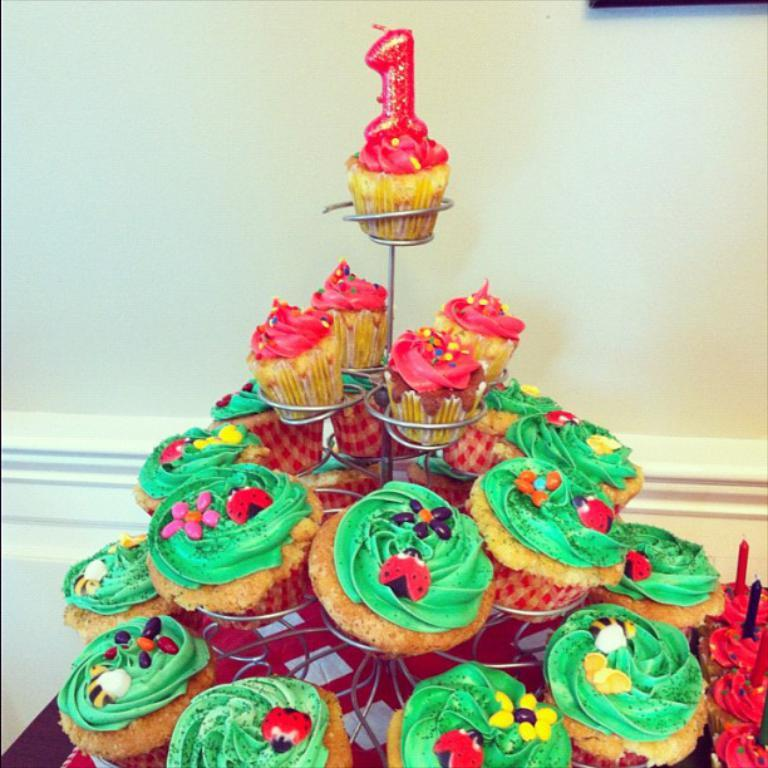What type of food is displayed on the stand in the image? There are muffins on a stand in the image. What is placed on top of the muffins? There are candles on the muffins. What can be seen in the background of the image? There is a wall in the background of the image. How many women are working in the industry depicted in the image? There is no industry or women present in the image; it features muffins with candles on a stand and a wall in the background. 